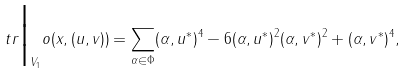<formula> <loc_0><loc_0><loc_500><loc_500>\ t r \Big | _ { V _ { 1 } } o ( x , ( u , v ) ) = \sum _ { \alpha \in \Phi } ( \alpha , u ^ { * } ) ^ { 4 } - 6 ( \alpha , u ^ { * } ) ^ { 2 } ( \alpha , v ^ { * } ) ^ { 2 } + ( \alpha , v ^ { * } ) ^ { 4 } ,</formula> 